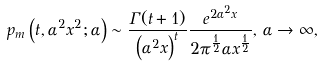Convert formula to latex. <formula><loc_0><loc_0><loc_500><loc_500>p _ { m } \left ( t , \alpha ^ { 2 } x ^ { 2 } ; \alpha \right ) \sim \frac { \Gamma ( t + 1 ) } { \left ( \alpha ^ { 2 } x \right ) ^ { t } } \frac { e ^ { 2 \alpha ^ { 2 } x } } { 2 \pi ^ { \frac { 1 } { 2 } } \alpha x ^ { \frac { 1 } { 2 } } } , \, \alpha \rightarrow \infty ,</formula> 